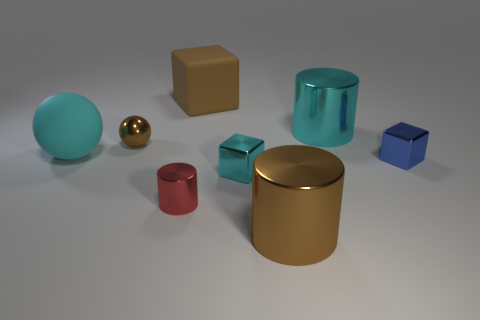Add 2 blue objects. How many objects exist? 10 Subtract all cylinders. How many objects are left? 5 Add 3 big matte things. How many big matte things are left? 5 Add 1 blue things. How many blue things exist? 2 Subtract 0 gray cylinders. How many objects are left? 8 Subtract all objects. Subtract all large cyan matte blocks. How many objects are left? 0 